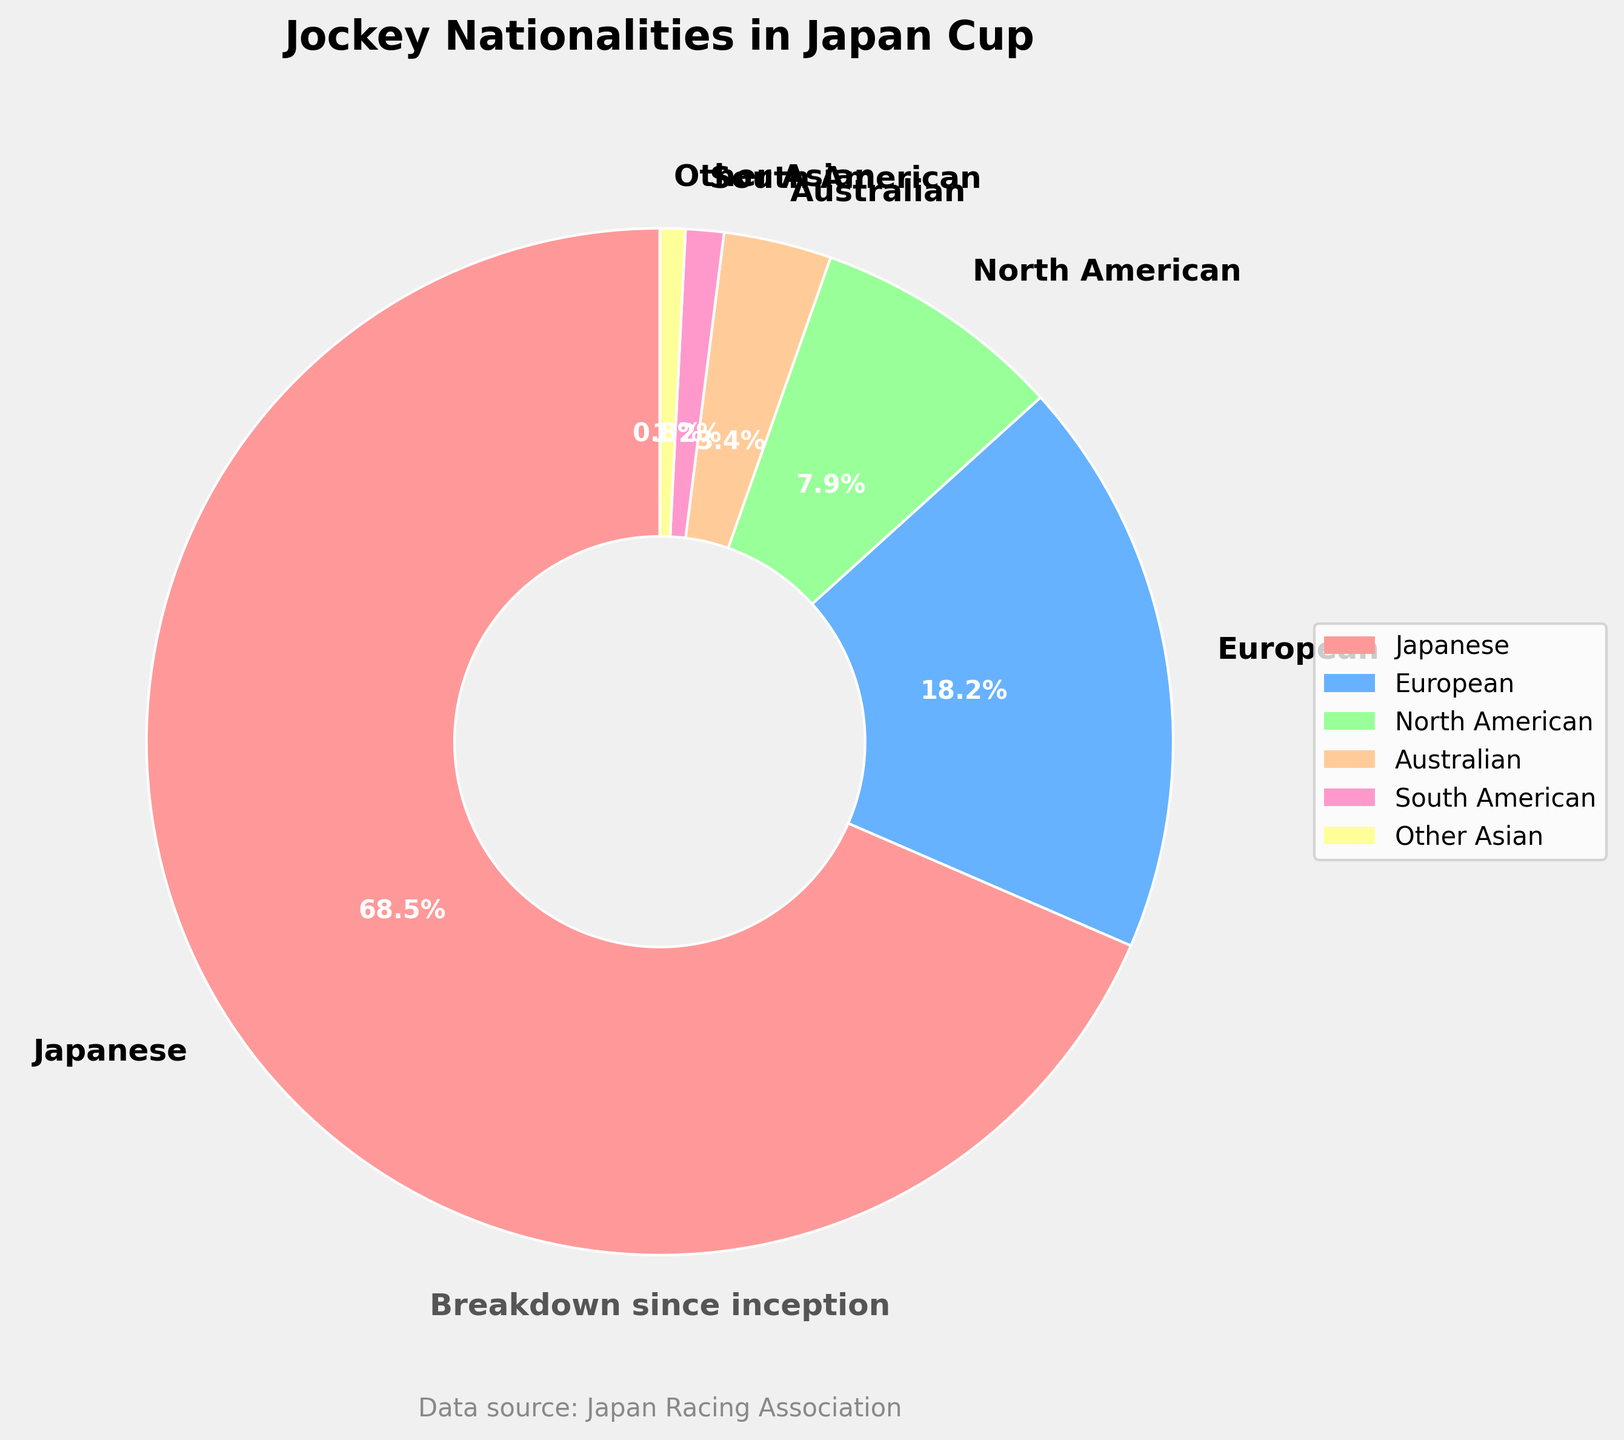Which nationality has the highest percentage of jockeys in the Japan Cup? Referring to the pie chart, the slice with the label "Japanese" takes up the largest portion of the chart, indicating that Japanese jockeys make up the highest percentage.
Answer: Japanese How much larger is the percentage of Japanese jockeys compared to European jockeys? From the pie chart, Japanese jockeys account for 68.5% and European jockeys account for 18.2%. The difference is 68.5% - 18.2% = 50.3%.
Answer: 50.3% What percentage of jockeys are from North America, Australia, and South America combined? The percentages for North American, Australian, and South American jockeys are 7.9%, 3.4%, and 1.2% respectively. Adding these gives 7.9% + 3.4% + 1.2% = 12.5%.
Answer: 12.5% Which segment is visually represented by a yellow color? The pie chart shows that the yellow segment corresponds to "Other Asian," judging by the color shades used in the chart.
Answer: Other Asian What is the combined percentage of jockeys from continents other than Asia? The applicable continents are Europe, North America, Australia, and South America. Summing their percentages: 18.2% (Europe) + 7.9% (North America) + 3.4% (Australia) + 1.2% (South America) = 30.7%.
Answer: 30.7% By how many times is the percentage of Japanese jockeys greater than Australian jockeys? To find how many times larger the Japanese jockey percentage is compared to the Australian, we divide the Japanese percentage by the Australian percentage: 68.5 / 3.4 ≈ 20.15.
Answer: About 20 times Which nationality has the smallest representation in the Japan Cup? From the pie chart, the smallest slice belongs to "Other Asian" with 0.8%.
Answer: Other Asian If you combine the percentages of European and Japanese jockeys, what fraction of the total do they represent? The combined percentages of European and Japanese jockeys are 18.2% and 68.5%, respectively. Adding these gives 18.2% + 68.5% = 86.7%. Converting this percentage to a fraction: 86.7/100 = 0.867, or 86.7%.
Answer: 86.7% 